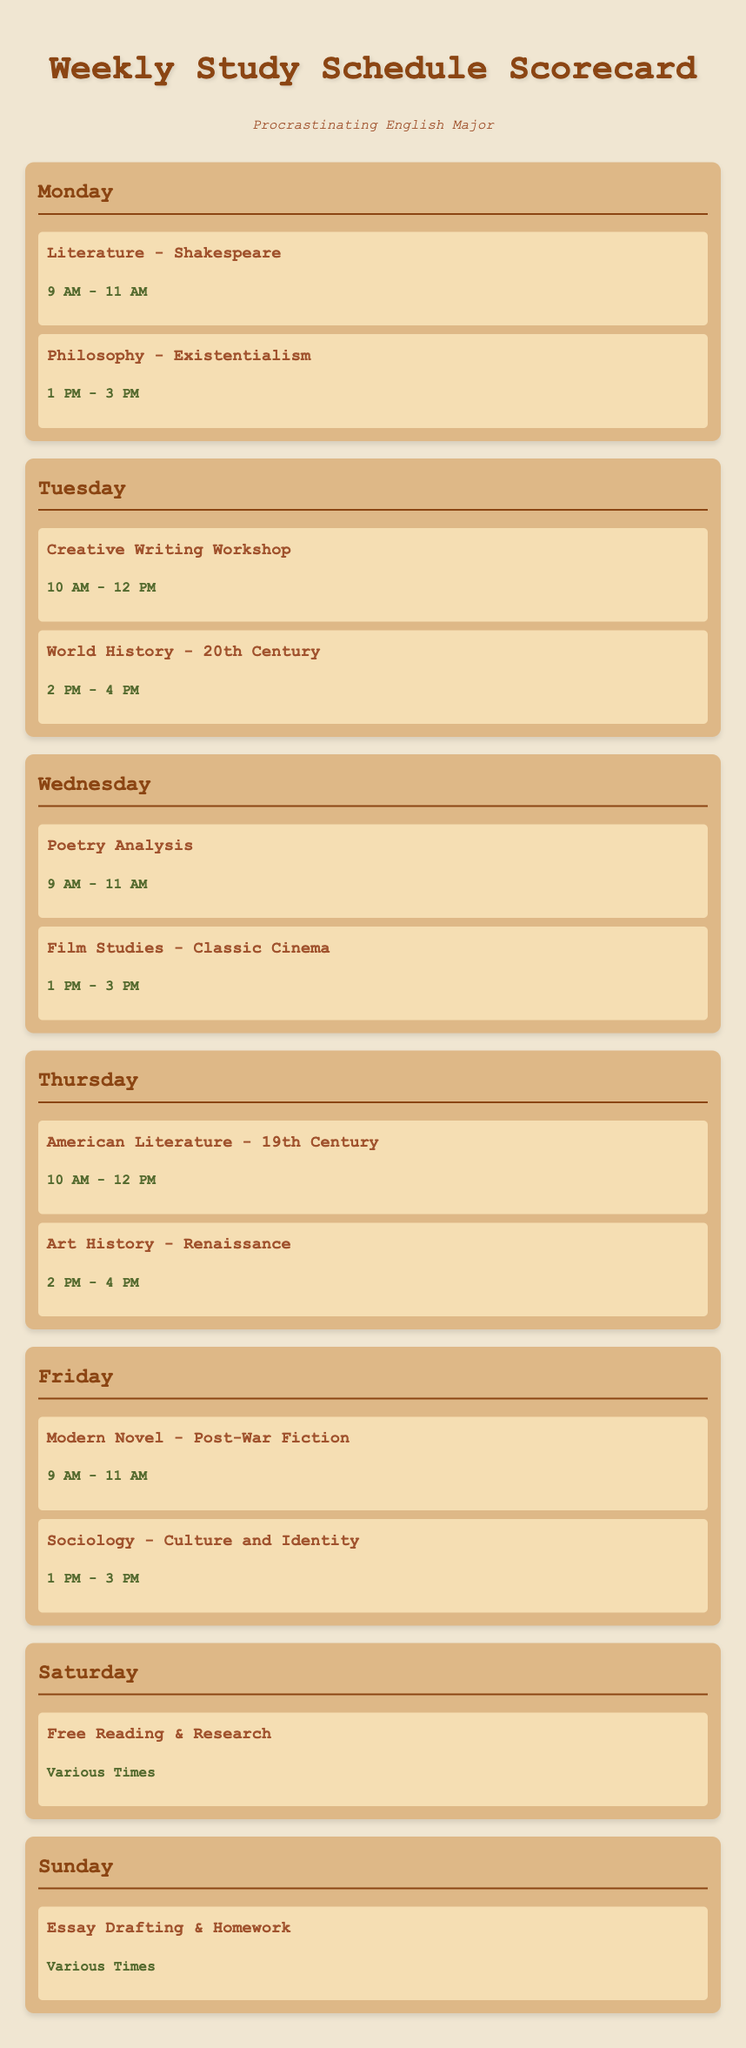What subjects are studied on Monday? Monday has two subjects: Literature - Shakespeare and Philosophy - Existentialism.
Answer: Literature - Shakespeare, Philosophy - Existentialism How many hours are allocated for Creative Writing Workshop on Tuesday? The time for Creative Writing Workshop on Tuesday is from 10 AM to 12 PM, which is 2 hours.
Answer: 2 hours What is the first subject studied on Friday? The first subject on Friday is Modern Novel - Post-War Fiction.
Answer: Modern Novel - Post-War Fiction Which day has a subject focused on Free Reading & Research? Free Reading & Research is scheduled on Saturday.
Answer: Saturday What time does Poetry Analysis start on Wednesday? Poetry Analysis starts at 9 AM on Wednesday.
Answer: 9 AM How many subjects are studied in total from Monday to Friday? Counting all subjects from Monday to Friday gives us 10 subjects.
Answer: 10 subjects What is the theme of the subject studied on Thursday from 10 AM to 12 PM? The subject studied during this time on Thursday is American Literature - 19th Century.
Answer: American Literature - 19th Century Which subject is scheduled during the afternoon on Tuesday? The subject scheduled in the afternoon on Tuesday is World History - 20th Century.
Answer: World History - 20th Century What activities are planned for Sunday? On Sunday, the planned activities are Essay Drafting & Homework.
Answer: Essay Drafting & Homework 